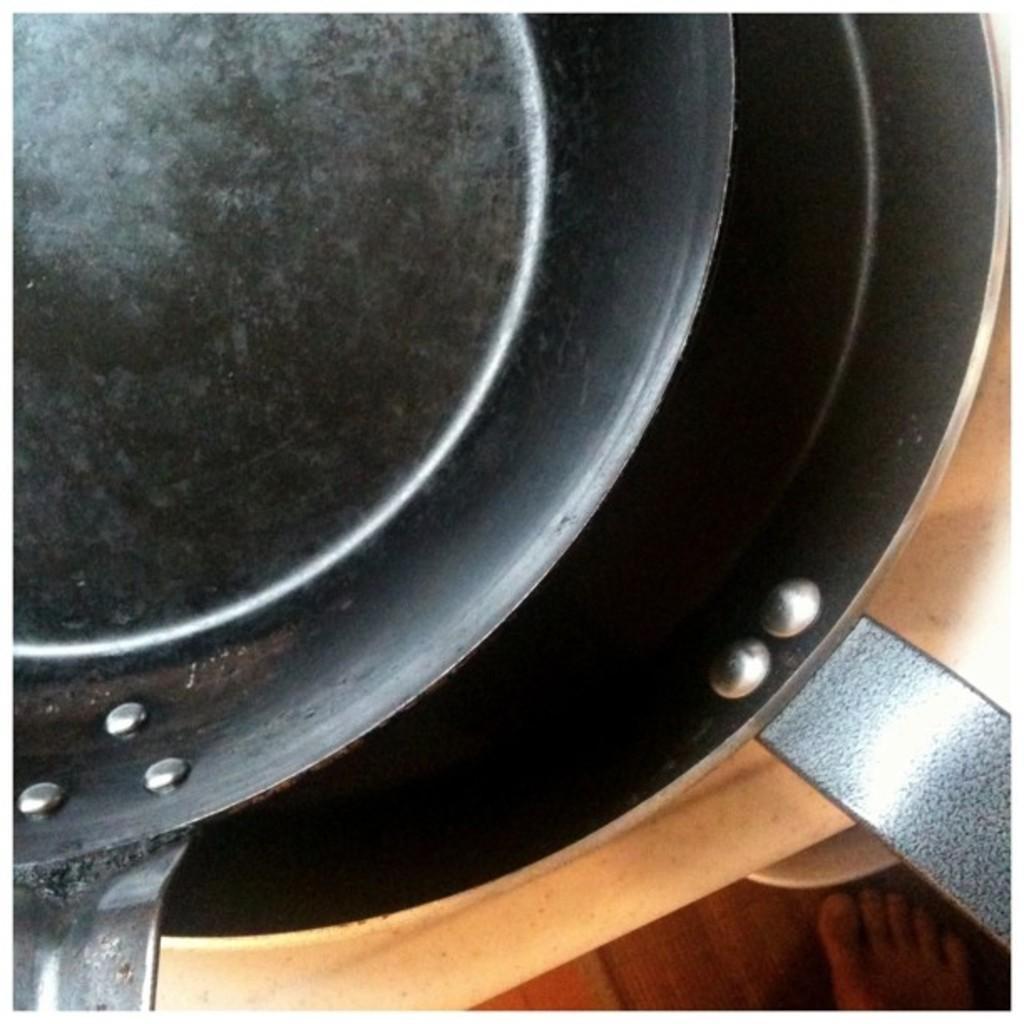Can you describe this image briefly? In this image we can see pans on a platform and at the bottom we can see foot of a person on the floor. 